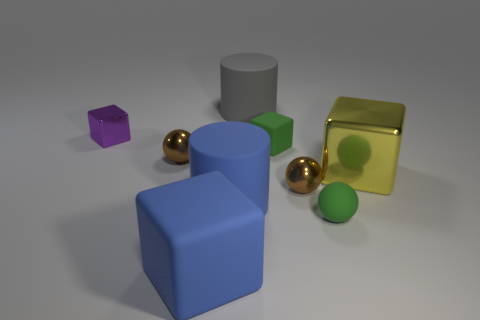Which objects in this image appear to have textures that would feel smooth to the touch? The objects that would likely feel smooth to the touch are the two golden spheres, due to their shiny, reflective surfaces, and the green and gold cubes that have polished, flat faces. 